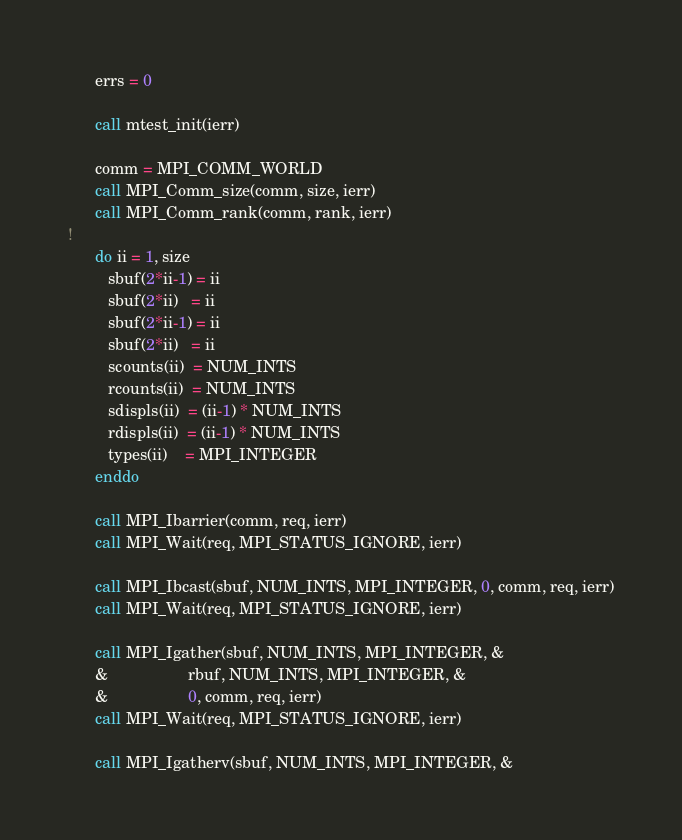Convert code to text. <code><loc_0><loc_0><loc_500><loc_500><_FORTRAN_>      errs = 0

      call mtest_init(ierr)

      comm = MPI_COMM_WORLD
      call MPI_Comm_size(comm, size, ierr)
      call MPI_Comm_rank(comm, rank, ierr)
!
      do ii = 1, size
         sbuf(2*ii-1) = ii
         sbuf(2*ii)   = ii
         sbuf(2*ii-1) = ii
         sbuf(2*ii)   = ii
         scounts(ii)  = NUM_INTS
         rcounts(ii)  = NUM_INTS
         sdispls(ii)  = (ii-1) * NUM_INTS
         rdispls(ii)  = (ii-1) * NUM_INTS
         types(ii)    = MPI_INTEGER
      enddo

      call MPI_Ibarrier(comm, req, ierr)
      call MPI_Wait(req, MPI_STATUS_IGNORE, ierr)

      call MPI_Ibcast(sbuf, NUM_INTS, MPI_INTEGER, 0, comm, req, ierr)
      call MPI_Wait(req, MPI_STATUS_IGNORE, ierr)

      call MPI_Igather(sbuf, NUM_INTS, MPI_INTEGER, &
      &                  rbuf, NUM_INTS, MPI_INTEGER, &
      &                  0, comm, req, ierr)
      call MPI_Wait(req, MPI_STATUS_IGNORE, ierr)

      call MPI_Igatherv(sbuf, NUM_INTS, MPI_INTEGER, &</code> 